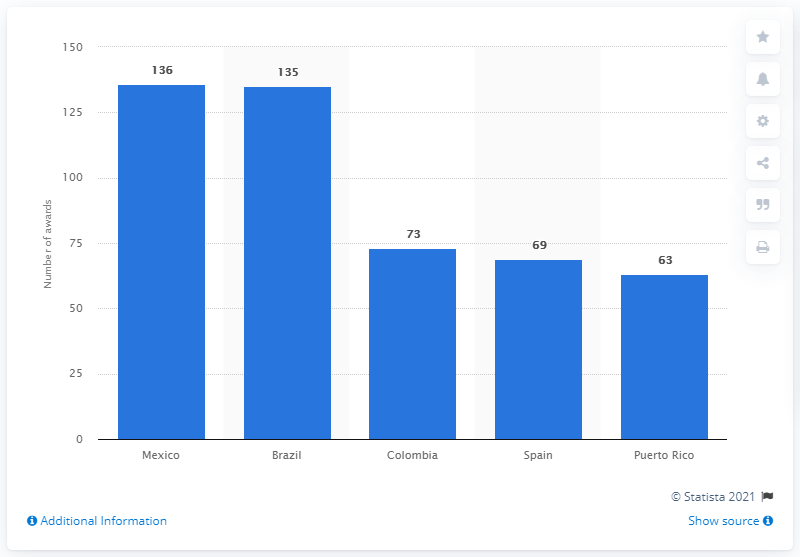Specify some key components in this picture. Mexico has received a total of 136 Latin Grammys as of now. 